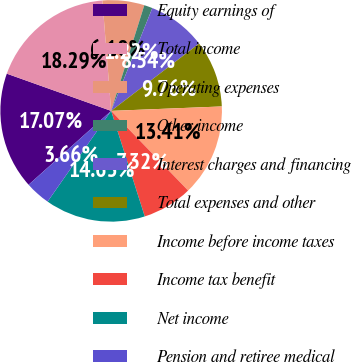<chart> <loc_0><loc_0><loc_500><loc_500><pie_chart><fcel>Equity earnings of<fcel>Total income<fcel>Operating expenses<fcel>Other income<fcel>Interest charges and financing<fcel>Total expenses and other<fcel>Income before income taxes<fcel>Income tax benefit<fcel>Net income<fcel>Pension and retiree medical<nl><fcel>17.07%<fcel>18.29%<fcel>6.1%<fcel>1.22%<fcel>8.54%<fcel>9.76%<fcel>13.41%<fcel>7.32%<fcel>14.63%<fcel>3.66%<nl></chart> 